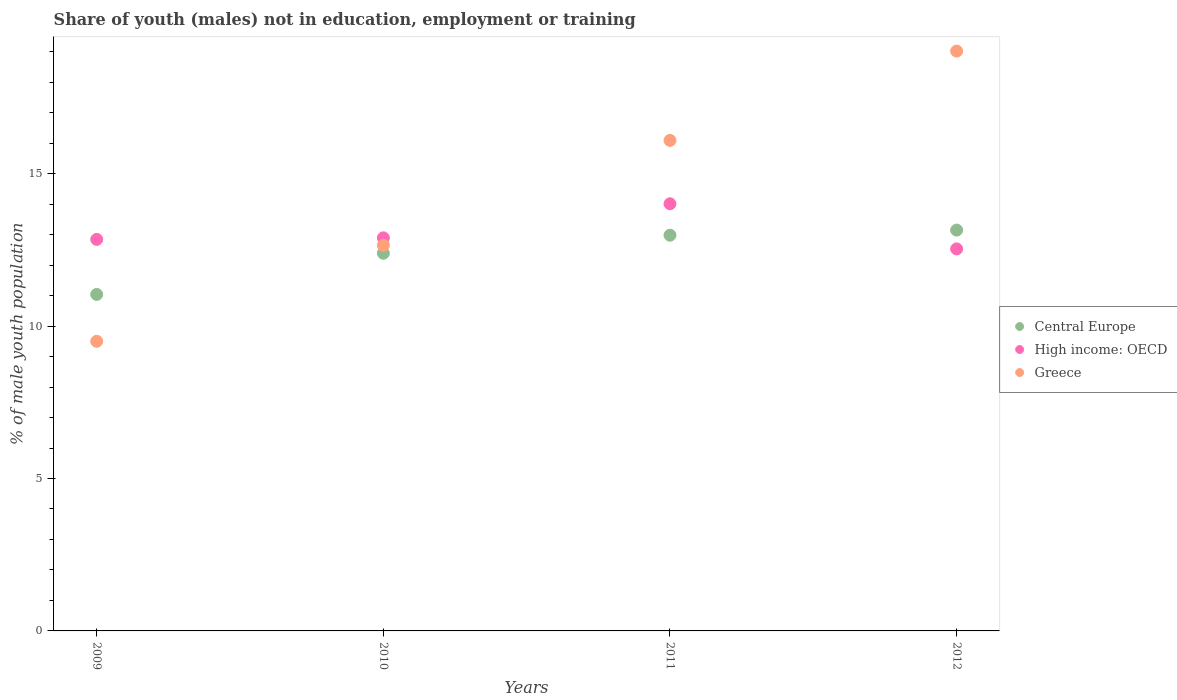How many different coloured dotlines are there?
Provide a succinct answer. 3. Is the number of dotlines equal to the number of legend labels?
Your answer should be very brief. Yes. Across all years, what is the maximum percentage of unemployed males population in in High income: OECD?
Make the answer very short. 14.01. Across all years, what is the minimum percentage of unemployed males population in in Greece?
Your answer should be compact. 9.5. In which year was the percentage of unemployed males population in in Central Europe maximum?
Provide a succinct answer. 2012. In which year was the percentage of unemployed males population in in Central Europe minimum?
Make the answer very short. 2009. What is the total percentage of unemployed males population in in Greece in the graph?
Give a very brief answer. 57.26. What is the difference between the percentage of unemployed males population in in Central Europe in 2011 and that in 2012?
Your answer should be very brief. -0.17. What is the difference between the percentage of unemployed males population in in Central Europe in 2009 and the percentage of unemployed males population in in High income: OECD in 2010?
Keep it short and to the point. -1.86. What is the average percentage of unemployed males population in in Greece per year?
Provide a short and direct response. 14.32. In the year 2010, what is the difference between the percentage of unemployed males population in in Central Europe and percentage of unemployed males population in in High income: OECD?
Ensure brevity in your answer.  -0.51. In how many years, is the percentage of unemployed males population in in Greece greater than 3 %?
Your answer should be very brief. 4. What is the ratio of the percentage of unemployed males population in in Central Europe in 2011 to that in 2012?
Your answer should be compact. 0.99. Is the difference between the percentage of unemployed males population in in Central Europe in 2009 and 2011 greater than the difference between the percentage of unemployed males population in in High income: OECD in 2009 and 2011?
Provide a succinct answer. No. What is the difference between the highest and the second highest percentage of unemployed males population in in High income: OECD?
Keep it short and to the point. 1.12. What is the difference between the highest and the lowest percentage of unemployed males population in in Greece?
Keep it short and to the point. 9.52. Is the sum of the percentage of unemployed males population in in Central Europe in 2011 and 2012 greater than the maximum percentage of unemployed males population in in Greece across all years?
Give a very brief answer. Yes. Does the percentage of unemployed males population in in High income: OECD monotonically increase over the years?
Make the answer very short. No. Is the percentage of unemployed males population in in Greece strictly greater than the percentage of unemployed males population in in High income: OECD over the years?
Your response must be concise. No. Is the percentage of unemployed males population in in High income: OECD strictly less than the percentage of unemployed males population in in Greece over the years?
Provide a short and direct response. No. How many dotlines are there?
Give a very brief answer. 3. How many years are there in the graph?
Ensure brevity in your answer.  4. Does the graph contain any zero values?
Keep it short and to the point. No. Does the graph contain grids?
Provide a succinct answer. No. How many legend labels are there?
Ensure brevity in your answer.  3. What is the title of the graph?
Offer a very short reply. Share of youth (males) not in education, employment or training. What is the label or title of the Y-axis?
Give a very brief answer. % of male youth population. What is the % of male youth population in Central Europe in 2009?
Give a very brief answer. 11.04. What is the % of male youth population of High income: OECD in 2009?
Offer a very short reply. 12.84. What is the % of male youth population of Central Europe in 2010?
Provide a succinct answer. 12.39. What is the % of male youth population of High income: OECD in 2010?
Keep it short and to the point. 12.89. What is the % of male youth population of Greece in 2010?
Give a very brief answer. 12.65. What is the % of male youth population in Central Europe in 2011?
Provide a short and direct response. 12.98. What is the % of male youth population of High income: OECD in 2011?
Your answer should be compact. 14.01. What is the % of male youth population of Greece in 2011?
Provide a short and direct response. 16.09. What is the % of male youth population in Central Europe in 2012?
Offer a terse response. 13.15. What is the % of male youth population in High income: OECD in 2012?
Give a very brief answer. 12.53. What is the % of male youth population of Greece in 2012?
Provide a succinct answer. 19.02. Across all years, what is the maximum % of male youth population in Central Europe?
Your answer should be compact. 13.15. Across all years, what is the maximum % of male youth population of High income: OECD?
Give a very brief answer. 14.01. Across all years, what is the maximum % of male youth population in Greece?
Offer a terse response. 19.02. Across all years, what is the minimum % of male youth population in Central Europe?
Give a very brief answer. 11.04. Across all years, what is the minimum % of male youth population in High income: OECD?
Your answer should be very brief. 12.53. Across all years, what is the minimum % of male youth population of Greece?
Provide a succinct answer. 9.5. What is the total % of male youth population in Central Europe in the graph?
Your answer should be compact. 49.55. What is the total % of male youth population in High income: OECD in the graph?
Offer a very short reply. 52.28. What is the total % of male youth population of Greece in the graph?
Keep it short and to the point. 57.26. What is the difference between the % of male youth population of Central Europe in 2009 and that in 2010?
Offer a terse response. -1.35. What is the difference between the % of male youth population in High income: OECD in 2009 and that in 2010?
Your answer should be very brief. -0.05. What is the difference between the % of male youth population of Greece in 2009 and that in 2010?
Give a very brief answer. -3.15. What is the difference between the % of male youth population of Central Europe in 2009 and that in 2011?
Your answer should be very brief. -1.94. What is the difference between the % of male youth population of High income: OECD in 2009 and that in 2011?
Keep it short and to the point. -1.17. What is the difference between the % of male youth population of Greece in 2009 and that in 2011?
Offer a very short reply. -6.59. What is the difference between the % of male youth population in Central Europe in 2009 and that in 2012?
Offer a very short reply. -2.11. What is the difference between the % of male youth population of High income: OECD in 2009 and that in 2012?
Your answer should be very brief. 0.31. What is the difference between the % of male youth population of Greece in 2009 and that in 2012?
Give a very brief answer. -9.52. What is the difference between the % of male youth population in Central Europe in 2010 and that in 2011?
Keep it short and to the point. -0.59. What is the difference between the % of male youth population of High income: OECD in 2010 and that in 2011?
Your response must be concise. -1.12. What is the difference between the % of male youth population in Greece in 2010 and that in 2011?
Provide a short and direct response. -3.44. What is the difference between the % of male youth population of Central Europe in 2010 and that in 2012?
Make the answer very short. -0.76. What is the difference between the % of male youth population in High income: OECD in 2010 and that in 2012?
Your answer should be very brief. 0.36. What is the difference between the % of male youth population in Greece in 2010 and that in 2012?
Provide a succinct answer. -6.37. What is the difference between the % of male youth population in Central Europe in 2011 and that in 2012?
Your response must be concise. -0.17. What is the difference between the % of male youth population of High income: OECD in 2011 and that in 2012?
Make the answer very short. 1.48. What is the difference between the % of male youth population of Greece in 2011 and that in 2012?
Provide a succinct answer. -2.93. What is the difference between the % of male youth population of Central Europe in 2009 and the % of male youth population of High income: OECD in 2010?
Your answer should be compact. -1.86. What is the difference between the % of male youth population of Central Europe in 2009 and the % of male youth population of Greece in 2010?
Make the answer very short. -1.61. What is the difference between the % of male youth population in High income: OECD in 2009 and the % of male youth population in Greece in 2010?
Your answer should be very brief. 0.19. What is the difference between the % of male youth population in Central Europe in 2009 and the % of male youth population in High income: OECD in 2011?
Offer a terse response. -2.97. What is the difference between the % of male youth population in Central Europe in 2009 and the % of male youth population in Greece in 2011?
Provide a succinct answer. -5.05. What is the difference between the % of male youth population of High income: OECD in 2009 and the % of male youth population of Greece in 2011?
Your answer should be very brief. -3.25. What is the difference between the % of male youth population of Central Europe in 2009 and the % of male youth population of High income: OECD in 2012?
Give a very brief answer. -1.49. What is the difference between the % of male youth population in Central Europe in 2009 and the % of male youth population in Greece in 2012?
Your response must be concise. -7.98. What is the difference between the % of male youth population of High income: OECD in 2009 and the % of male youth population of Greece in 2012?
Keep it short and to the point. -6.18. What is the difference between the % of male youth population in Central Europe in 2010 and the % of male youth population in High income: OECD in 2011?
Give a very brief answer. -1.62. What is the difference between the % of male youth population in Central Europe in 2010 and the % of male youth population in Greece in 2011?
Offer a very short reply. -3.7. What is the difference between the % of male youth population of High income: OECD in 2010 and the % of male youth population of Greece in 2011?
Provide a succinct answer. -3.2. What is the difference between the % of male youth population in Central Europe in 2010 and the % of male youth population in High income: OECD in 2012?
Offer a very short reply. -0.14. What is the difference between the % of male youth population of Central Europe in 2010 and the % of male youth population of Greece in 2012?
Provide a succinct answer. -6.63. What is the difference between the % of male youth population in High income: OECD in 2010 and the % of male youth population in Greece in 2012?
Offer a terse response. -6.13. What is the difference between the % of male youth population of Central Europe in 2011 and the % of male youth population of High income: OECD in 2012?
Ensure brevity in your answer.  0.45. What is the difference between the % of male youth population of Central Europe in 2011 and the % of male youth population of Greece in 2012?
Your response must be concise. -6.04. What is the difference between the % of male youth population of High income: OECD in 2011 and the % of male youth population of Greece in 2012?
Give a very brief answer. -5.01. What is the average % of male youth population of Central Europe per year?
Your answer should be compact. 12.39. What is the average % of male youth population in High income: OECD per year?
Offer a very short reply. 13.07. What is the average % of male youth population of Greece per year?
Your answer should be very brief. 14.31. In the year 2009, what is the difference between the % of male youth population of Central Europe and % of male youth population of High income: OECD?
Offer a terse response. -1.81. In the year 2009, what is the difference between the % of male youth population in Central Europe and % of male youth population in Greece?
Ensure brevity in your answer.  1.54. In the year 2009, what is the difference between the % of male youth population of High income: OECD and % of male youth population of Greece?
Offer a terse response. 3.34. In the year 2010, what is the difference between the % of male youth population in Central Europe and % of male youth population in High income: OECD?
Give a very brief answer. -0.51. In the year 2010, what is the difference between the % of male youth population in Central Europe and % of male youth population in Greece?
Keep it short and to the point. -0.26. In the year 2010, what is the difference between the % of male youth population of High income: OECD and % of male youth population of Greece?
Make the answer very short. 0.24. In the year 2011, what is the difference between the % of male youth population of Central Europe and % of male youth population of High income: OECD?
Provide a short and direct response. -1.03. In the year 2011, what is the difference between the % of male youth population of Central Europe and % of male youth population of Greece?
Provide a succinct answer. -3.11. In the year 2011, what is the difference between the % of male youth population in High income: OECD and % of male youth population in Greece?
Your answer should be very brief. -2.08. In the year 2012, what is the difference between the % of male youth population of Central Europe and % of male youth population of High income: OECD?
Your answer should be compact. 0.62. In the year 2012, what is the difference between the % of male youth population in Central Europe and % of male youth population in Greece?
Offer a terse response. -5.87. In the year 2012, what is the difference between the % of male youth population of High income: OECD and % of male youth population of Greece?
Give a very brief answer. -6.49. What is the ratio of the % of male youth population in Central Europe in 2009 to that in 2010?
Keep it short and to the point. 0.89. What is the ratio of the % of male youth population of High income: OECD in 2009 to that in 2010?
Offer a very short reply. 1. What is the ratio of the % of male youth population of Greece in 2009 to that in 2010?
Give a very brief answer. 0.75. What is the ratio of the % of male youth population of Central Europe in 2009 to that in 2011?
Your response must be concise. 0.85. What is the ratio of the % of male youth population of High income: OECD in 2009 to that in 2011?
Offer a terse response. 0.92. What is the ratio of the % of male youth population in Greece in 2009 to that in 2011?
Offer a very short reply. 0.59. What is the ratio of the % of male youth population of Central Europe in 2009 to that in 2012?
Your answer should be very brief. 0.84. What is the ratio of the % of male youth population of High income: OECD in 2009 to that in 2012?
Offer a very short reply. 1.02. What is the ratio of the % of male youth population in Greece in 2009 to that in 2012?
Give a very brief answer. 0.5. What is the ratio of the % of male youth population of Central Europe in 2010 to that in 2011?
Ensure brevity in your answer.  0.95. What is the ratio of the % of male youth population in High income: OECD in 2010 to that in 2011?
Your response must be concise. 0.92. What is the ratio of the % of male youth population of Greece in 2010 to that in 2011?
Ensure brevity in your answer.  0.79. What is the ratio of the % of male youth population in Central Europe in 2010 to that in 2012?
Your answer should be compact. 0.94. What is the ratio of the % of male youth population of High income: OECD in 2010 to that in 2012?
Provide a succinct answer. 1.03. What is the ratio of the % of male youth population of Greece in 2010 to that in 2012?
Provide a short and direct response. 0.67. What is the ratio of the % of male youth population in Central Europe in 2011 to that in 2012?
Make the answer very short. 0.99. What is the ratio of the % of male youth population in High income: OECD in 2011 to that in 2012?
Your answer should be very brief. 1.12. What is the ratio of the % of male youth population in Greece in 2011 to that in 2012?
Make the answer very short. 0.85. What is the difference between the highest and the second highest % of male youth population in Central Europe?
Your answer should be very brief. 0.17. What is the difference between the highest and the second highest % of male youth population in High income: OECD?
Ensure brevity in your answer.  1.12. What is the difference between the highest and the second highest % of male youth population in Greece?
Provide a short and direct response. 2.93. What is the difference between the highest and the lowest % of male youth population in Central Europe?
Make the answer very short. 2.11. What is the difference between the highest and the lowest % of male youth population of High income: OECD?
Your response must be concise. 1.48. What is the difference between the highest and the lowest % of male youth population of Greece?
Your answer should be compact. 9.52. 